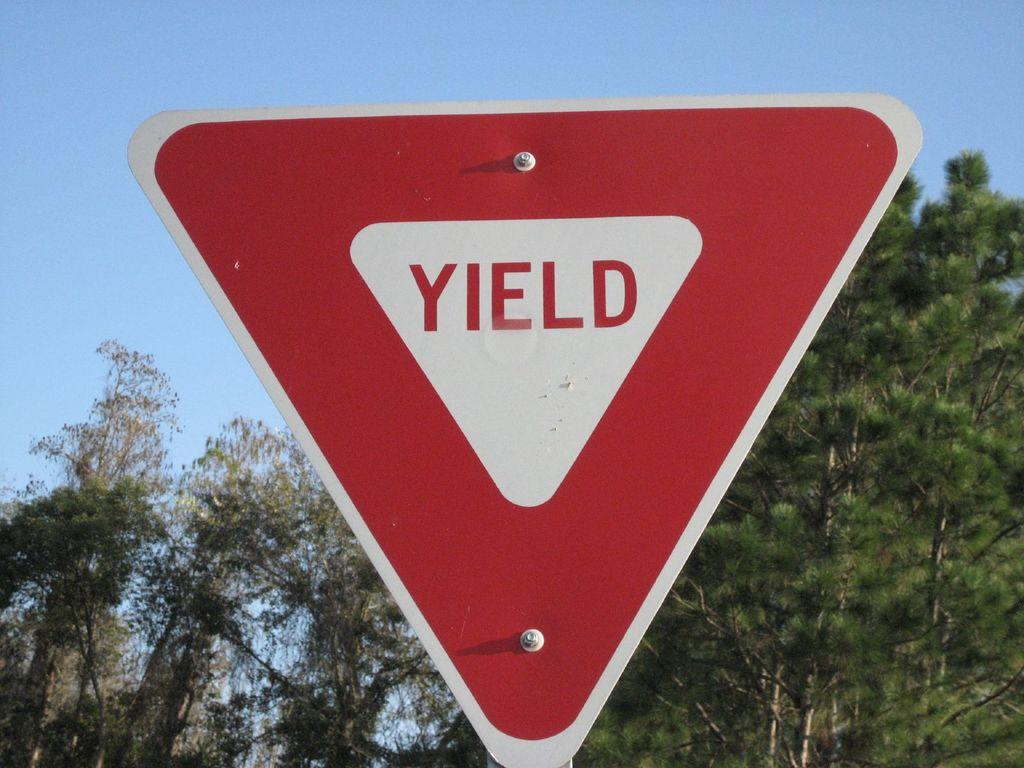<image>
Describe the image concisely. Red and white Yield sign in front of some trees. 